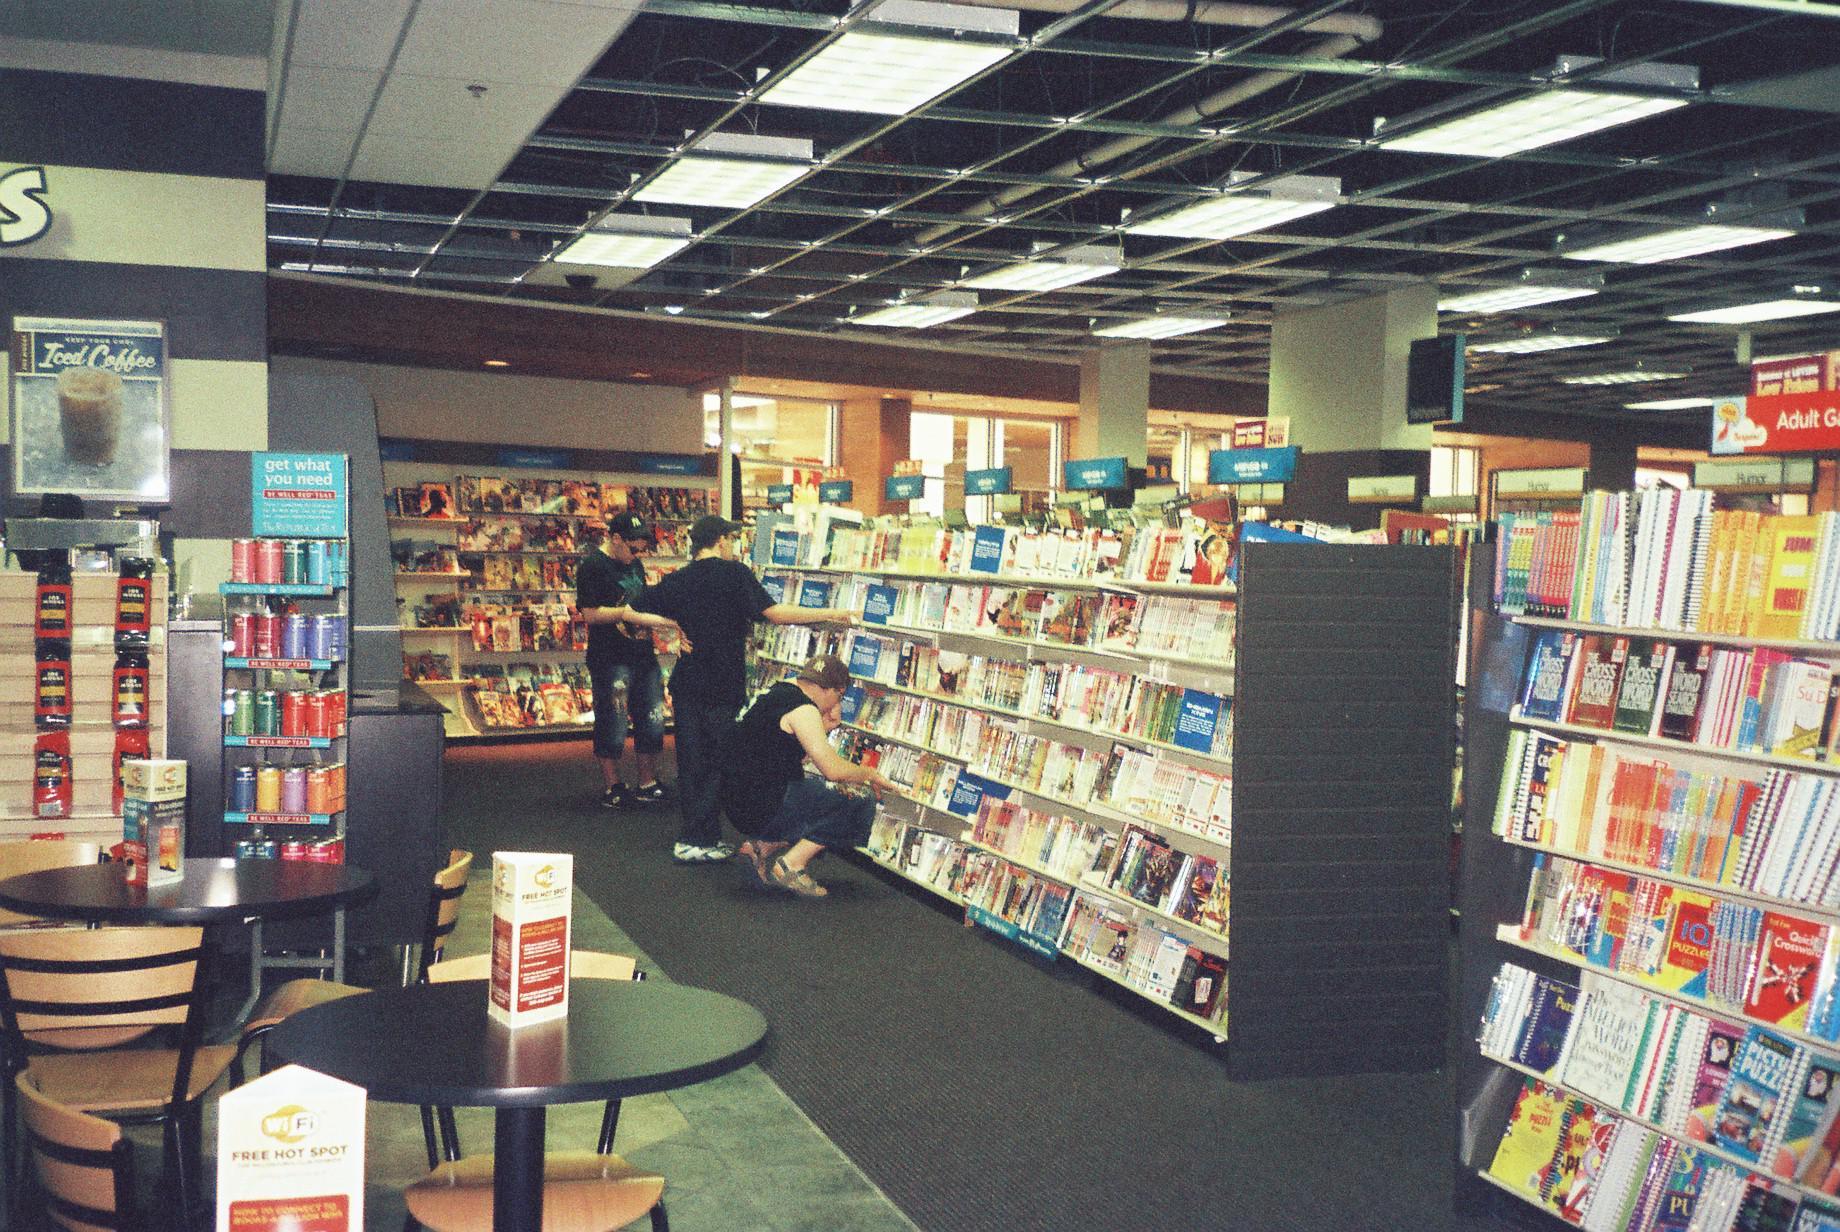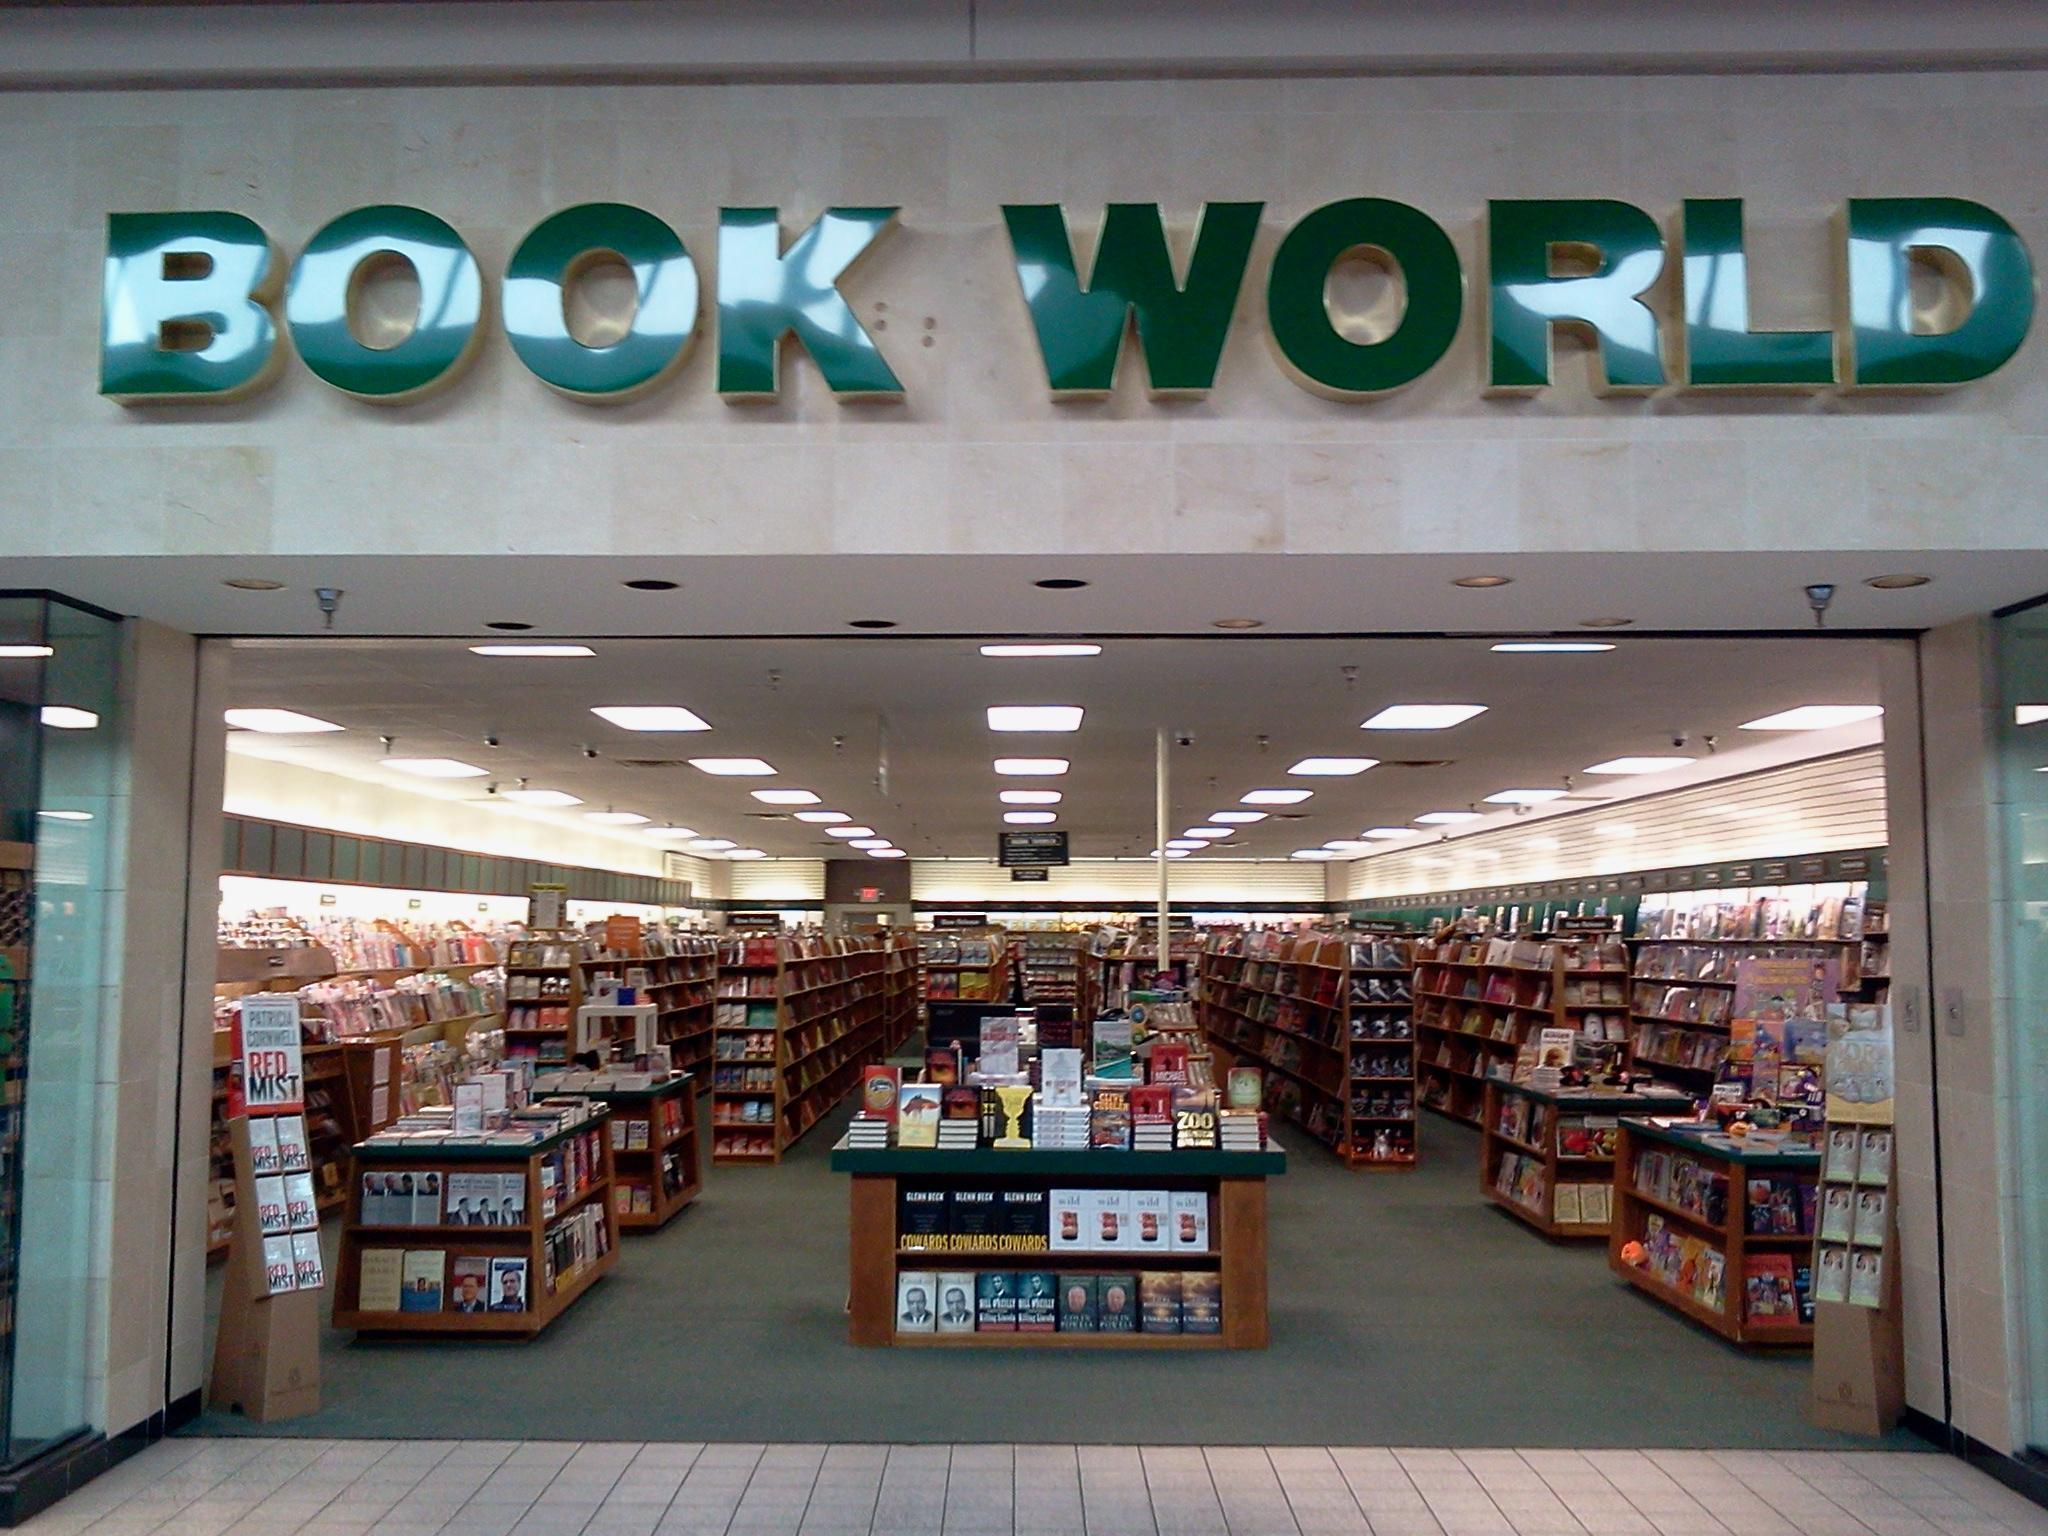The first image is the image on the left, the second image is the image on the right. For the images displayed, is the sentence "Outside store front view of used bookstores." factually correct? Answer yes or no. No. The first image is the image on the left, the second image is the image on the right. Given the left and right images, does the statement "there is a book shelf with books outside the front window of the book store" hold true? Answer yes or no. No. 